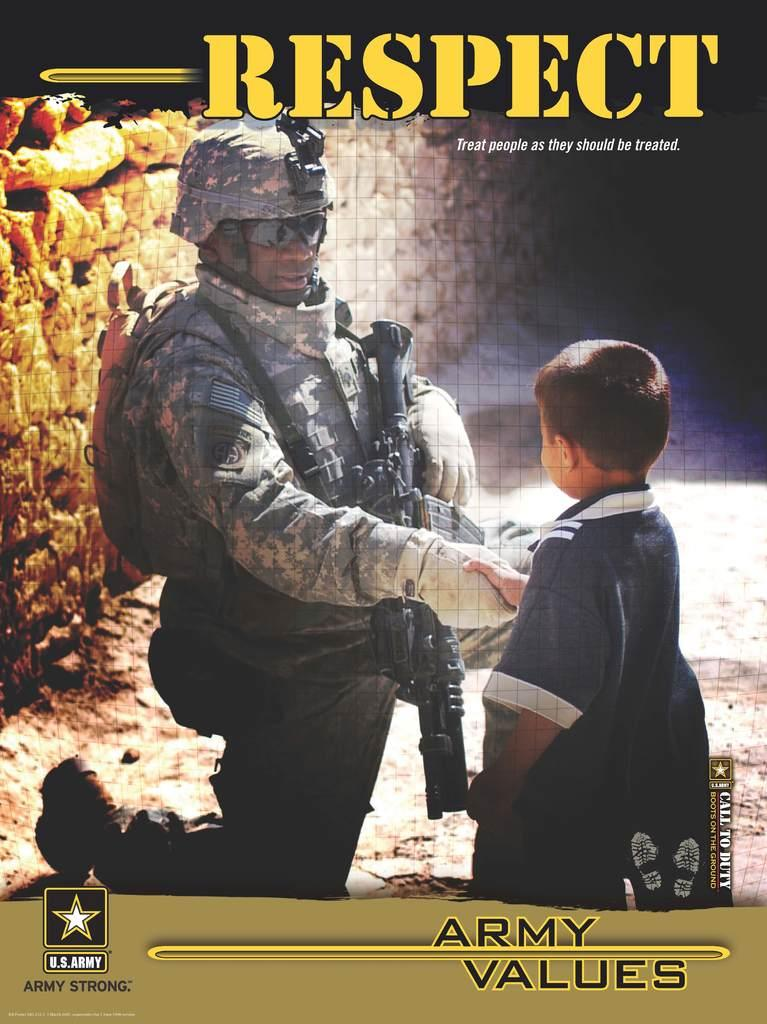What is the main subject of the image? The main subject of the image is a book cover. What action is being performed by the man and the boy in the image? The man and the boy are shaking hands in the center of the image. What is on the left side of the image? There is a wall on the left side of the image. What can be found at the top and bottom of the image? There is text at the top and bottom of the image. What type of quilt is being used as a prop in the image? There is no quilt present in the image. Can you hear the boy whistling in the image? There is no sound in the image, so it is impossible to determine if the boy is whistling. Is there a bee buzzing around the man and the boy in the image? There is no bee present in the image. 